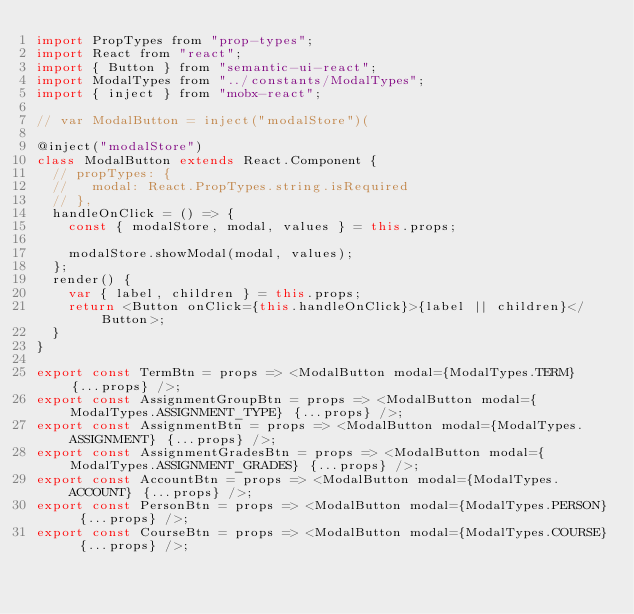Convert code to text. <code><loc_0><loc_0><loc_500><loc_500><_JavaScript_>import PropTypes from "prop-types";
import React from "react";
import { Button } from "semantic-ui-react";
import ModalTypes from "../constants/ModalTypes";
import { inject } from "mobx-react";

// var ModalButton = inject("modalStore")(

@inject("modalStore")
class ModalButton extends React.Component {
  // propTypes: {
  //   modal: React.PropTypes.string.isRequired
  // },
  handleOnClick = () => {
    const { modalStore, modal, values } = this.props;

    modalStore.showModal(modal, values);
  };
  render() {
    var { label, children } = this.props;
    return <Button onClick={this.handleOnClick}>{label || children}</Button>;
  }
}

export const TermBtn = props => <ModalButton modal={ModalTypes.TERM} {...props} />;
export const AssignmentGroupBtn = props => <ModalButton modal={ModalTypes.ASSIGNMENT_TYPE} {...props} />;
export const AssignmentBtn = props => <ModalButton modal={ModalTypes.ASSIGNMENT} {...props} />;
export const AssignmentGradesBtn = props => <ModalButton modal={ModalTypes.ASSIGNMENT_GRADES} {...props} />;
export const AccountBtn = props => <ModalButton modal={ModalTypes.ACCOUNT} {...props} />;
export const PersonBtn = props => <ModalButton modal={ModalTypes.PERSON} {...props} />;
export const CourseBtn = props => <ModalButton modal={ModalTypes.COURSE} {...props} />;
</code> 